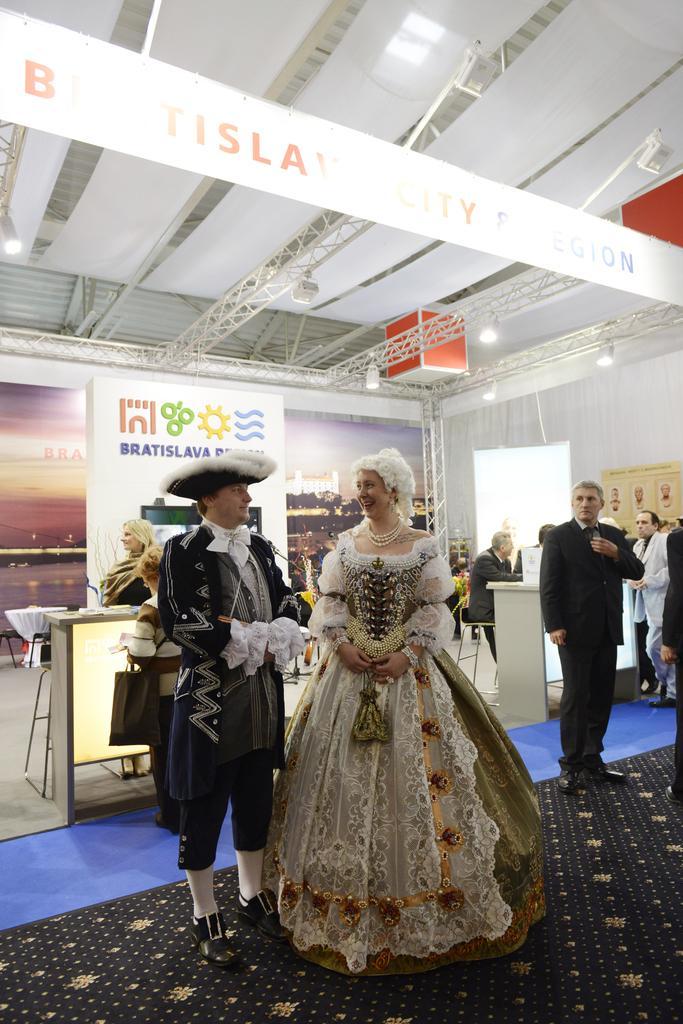How would you summarize this image in a sentence or two? There is a woman, she is wearing a heavy gown and around the woman there are some other people, some event is going on in the hall. Behind the woman there is a banner and a logo of some organisation in front of the banner, on the right side a person is sitting on a chair in front of a table and in the background there is a white wall and beside the wall there is a window. 